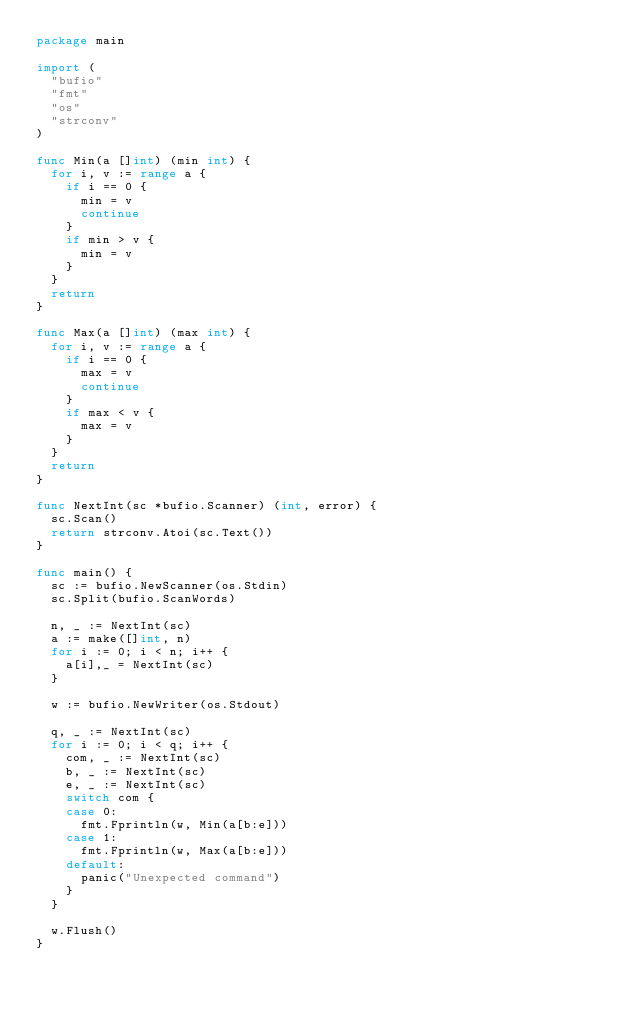Convert code to text. <code><loc_0><loc_0><loc_500><loc_500><_Go_>package main

import (
	"bufio"
	"fmt"
	"os"
	"strconv"
)

func Min(a []int) (min int) {
	for i, v := range a {
		if i == 0 {
			min = v
			continue
		}
		if min > v {
			min = v
		}
	}
	return
}

func Max(a []int) (max int) {
	for i, v := range a {
		if i == 0 {
			max = v
			continue
		}
		if max < v {
			max = v
		}
	}
	return
}

func NextInt(sc *bufio.Scanner) (int, error) {
	sc.Scan()
	return strconv.Atoi(sc.Text())
}

func main() {
	sc := bufio.NewScanner(os.Stdin)
	sc.Split(bufio.ScanWords)

	n, _ := NextInt(sc)
	a := make([]int, n)
	for i := 0; i < n; i++ {
		a[i],_ = NextInt(sc)
	}

	w := bufio.NewWriter(os.Stdout)

	q, _ := NextInt(sc)
	for i := 0; i < q; i++ {
		com, _ := NextInt(sc)
		b, _ := NextInt(sc)
		e, _ := NextInt(sc)
		switch com {
		case 0:
			fmt.Fprintln(w, Min(a[b:e]))
		case 1:
			fmt.Fprintln(w, Max(a[b:e]))
		default:
			panic("Unexpected command")
		}
	}

	w.Flush()
}

</code> 